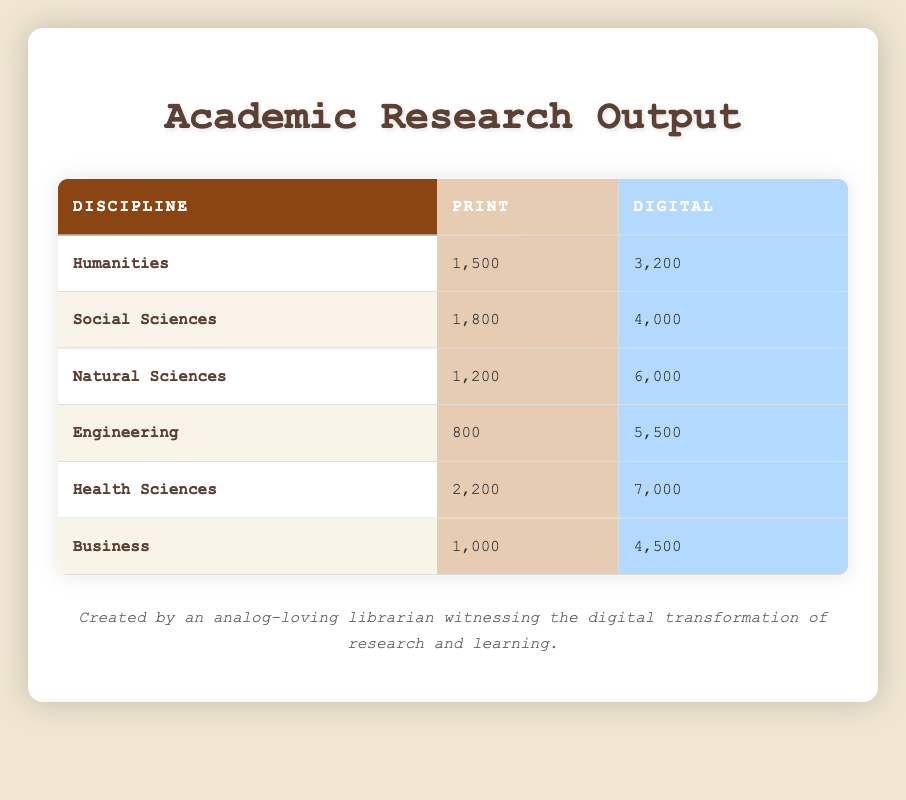What is the total print research output for all disciplines combined? To find the total print research output, we need to add the print values for each discipline: 1500 (Humanities) + 1800 (Social Sciences) + 1200 (Natural Sciences) + 800 (Engineering) + 2200 (Health Sciences) + 1000 (Business) = 9500
Answer: 9500 How many digital research outputs are there in the Engineering discipline? The digital research output for the Engineering discipline is directly given in the table as 5500
Answer: 5500 Is the digital research output in Health Sciences greater than in Business? The digital research output for Health Sciences is 7000 and for Business, it is 4500. Since 7000 is greater than 4500, the statement is true
Answer: Yes What is the difference in print research output between Health Sciences and Humanities? To find the difference, subtract the print output of Humanities (1500) from Health Sciences (2200): 2200 - 1500 = 700
Answer: 700 What is the average digital research output for all disciplines? To calculate the average, first sum the digital outputs: 3200 + 4000 + 6000 + 5500 + 7000 + 4500 = 30200. Then, divide by the number of disciplines (6): 30200 / 6 = 5033.33
Answer: 5033.33 Which discipline has the highest total research output when combining print and digital methods? To determine the total output for each discipline, add the print and digital values. For example, Humanities: 1500 + 3200 = 4700; Health Sciences: 2200 + 7000 = 9200. Continuing this for each discipline reveals that Health Sciences has the highest total: 9200
Answer: Health Sciences Are there more print outputs in the Social Sciences than in Natural Sciences? The print output for Social Sciences is 1800 and for Natural Sciences, it is 1200. Since 1800 is greater than 1200, the statement is true
Answer: Yes What is the total research output for Natural Sciences combining both print and digital? The total output for Natural Sciences can be found by adding its print and digital outputs: 1200 (Print) + 6000 (Digital) = 7200
Answer: 7200 How much greater is the digital output of the Natural Sciences than the Humanities? The digital output for Natural Sciences is 6000 and for Humanities, it is 3200. The difference is 6000 - 3200 = 2800
Answer: 2800 